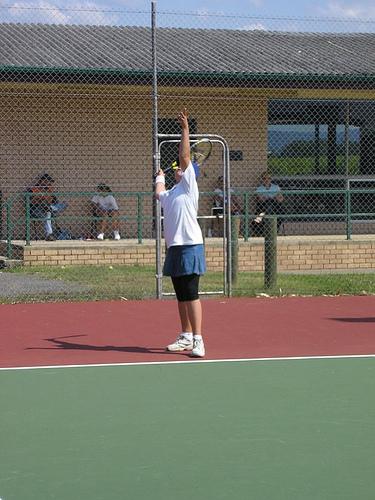What is the color of the court the woman is not standing in?
Short answer required. Green. Is the woman playing tennis?
Be succinct. Yes. What color is the woman's skirt?
Concise answer only. Blue. 